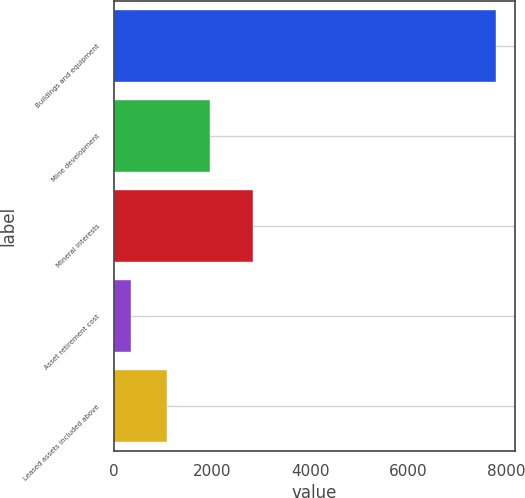<chart> <loc_0><loc_0><loc_500><loc_500><bar_chart><fcel>Buildings and equipment<fcel>Mine development<fcel>Mineral interests<fcel>Asset retirement cost<fcel>Leased assets included above<nl><fcel>7786<fcel>1951<fcel>2830<fcel>335<fcel>1080.1<nl></chart> 